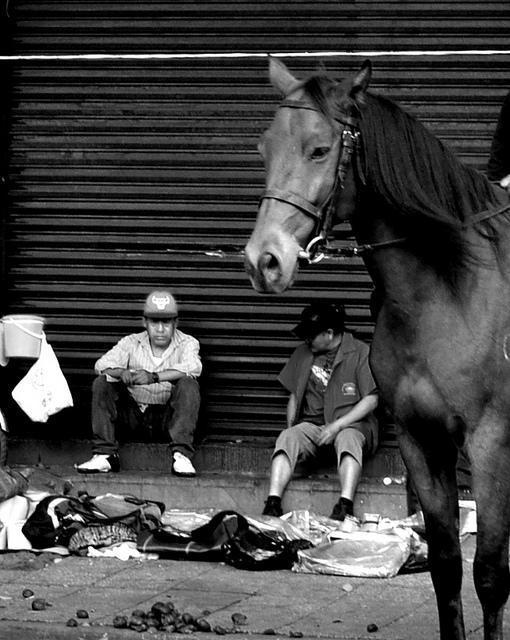How many of the horses legs are visible?
Give a very brief answer. 2. How many people are visible?
Give a very brief answer. 2. 